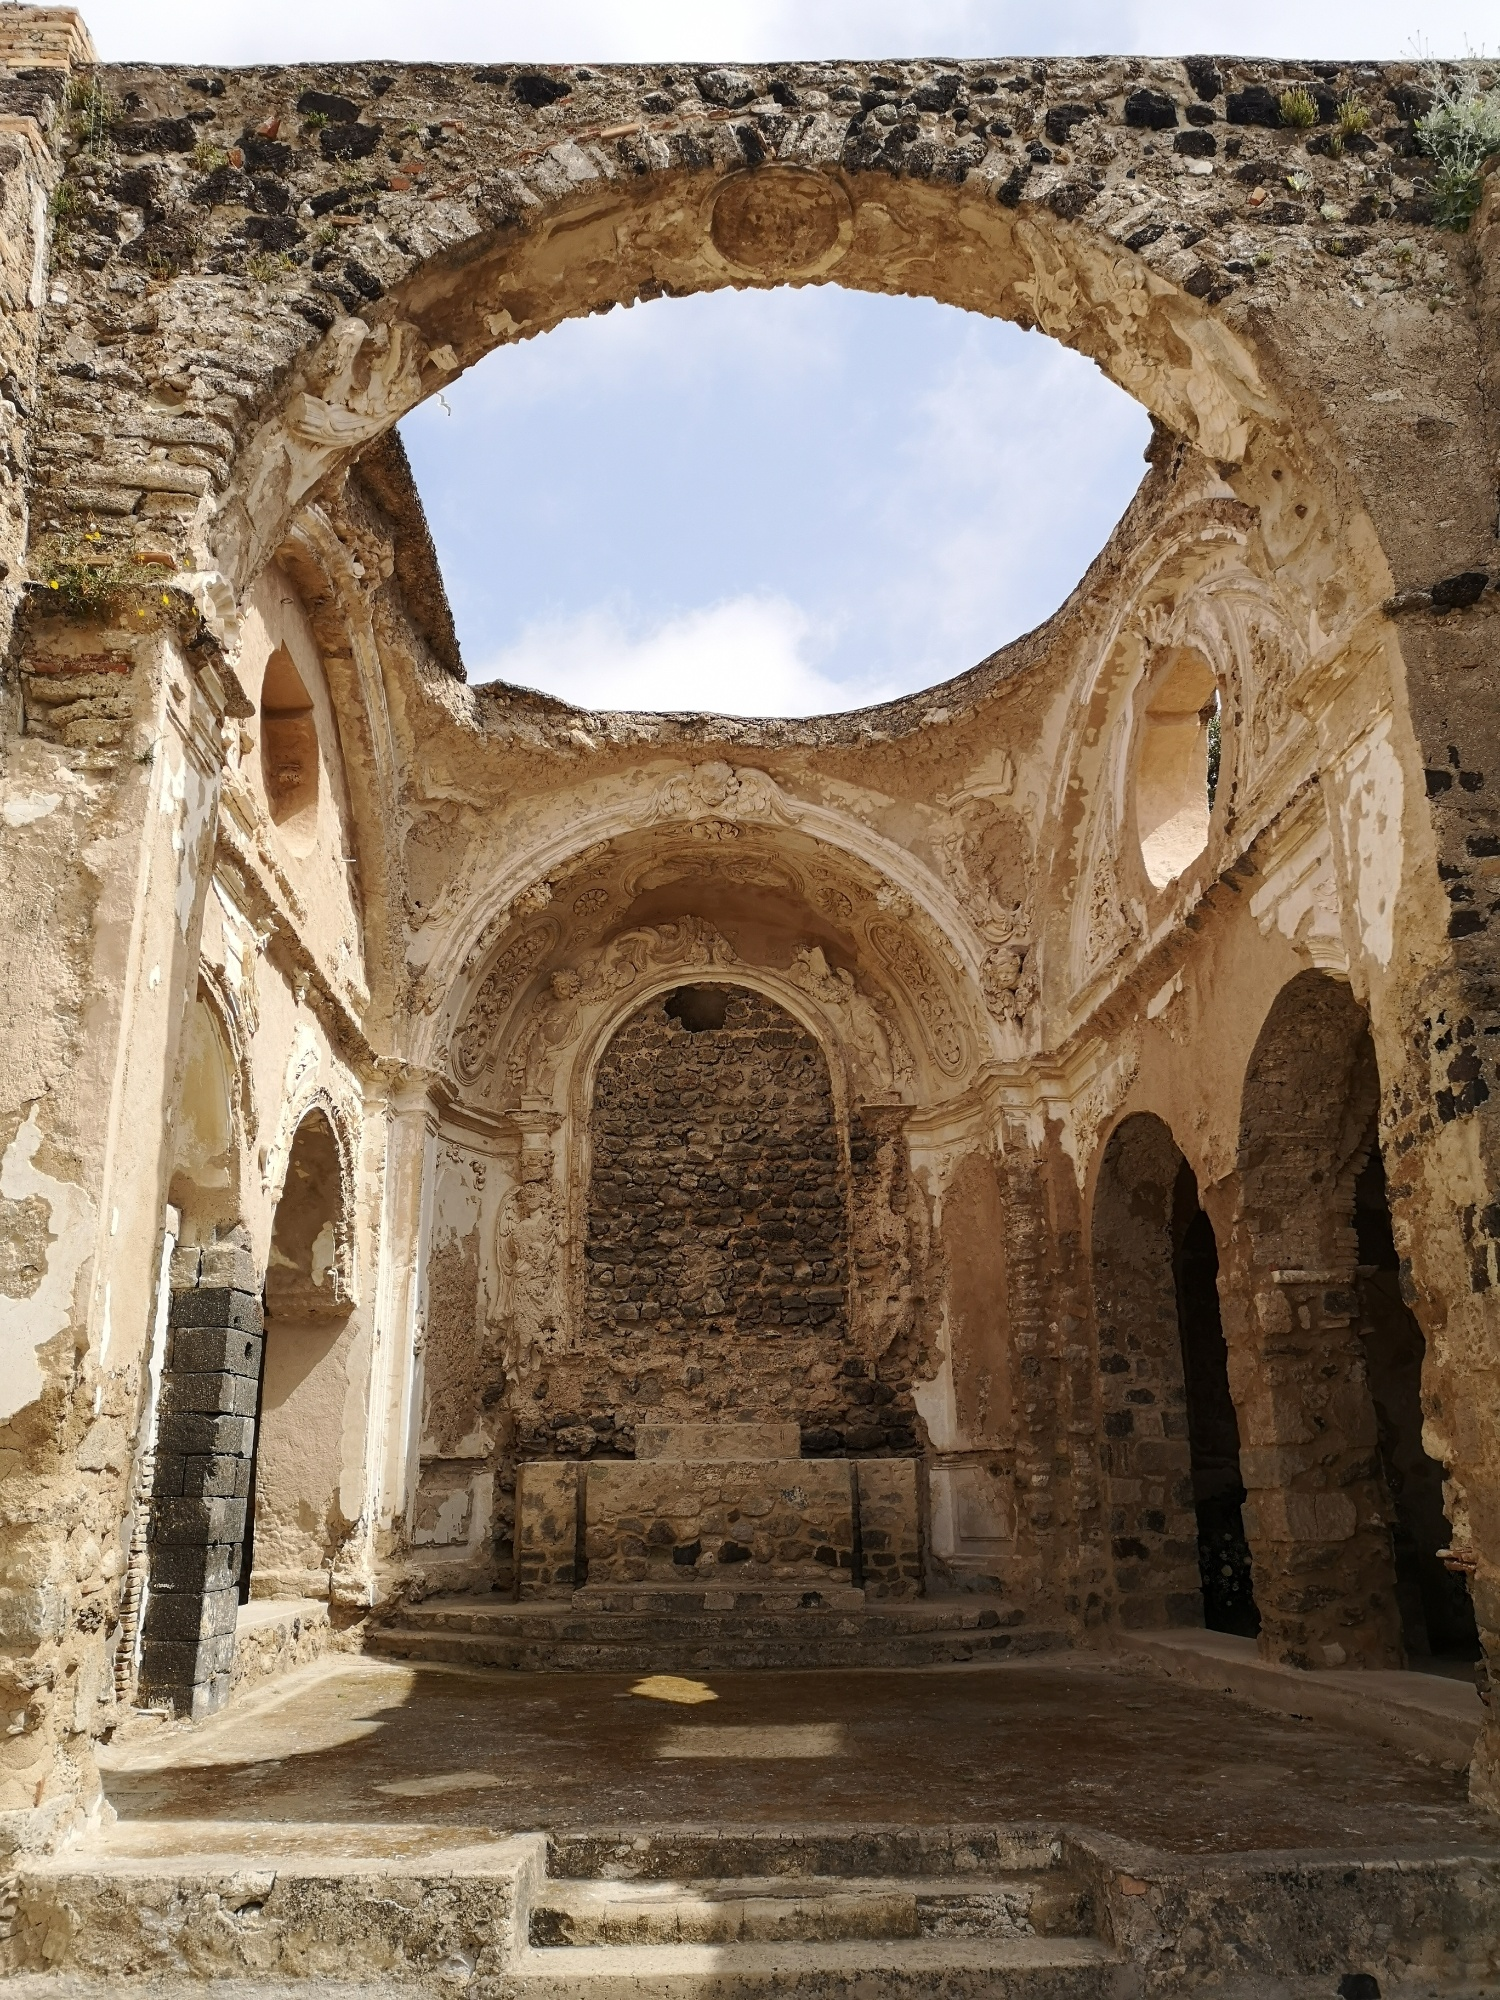Imagine this structure is a portal to another world. Where does it take you? Stepping through this ancient structure, you find yourself transported to a mystical realm where history, fantasy, and nature coexist in harmony. The ruins transform into a majestic cathedral, its arches leading to a lush enchanted forest filled with mythical creatures like unicorns and talking animals. Here, ancient trees with golden leaves whisper secrets of the past, and the air is filled with the sound of ethereal music. Time slows, and you are met by wise sorcerers and ethereal beings who guide you through a landscape where the past and future merge. The sky above is a tapestry of colors, with floating islands and castles in the clouds. This otherworldly place brims with magic and wonder, inviting you to embark on an endless adventure, discovering enchanted artifacts, and uncovering lost legends. How does the structure's history influence the culture of the people living nearby? The historical significance of the structure undoubtedly shapes the local culture in profound ways. Its presence likely fosters a deep sense of identity and pride among the community members. Traditions and festivals centered around the structure would keep the heritage alive, with younger generations being taught the importance of their historical roots. The craftsmanship and art of the structure may inspire local artisans, influencing contemporary art and architecture. The stories and legends associated with the structure are shared through oral traditions, literature, and performances, enriching the cultural tapestry of the region. The structure also attracts historians, tourists, and scholars, blending local customs with external influences, ultimately creating a vibrant, historically-rich cultural environment. 